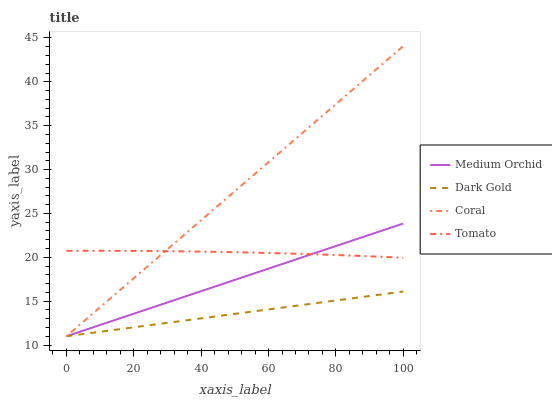Does Dark Gold have the minimum area under the curve?
Answer yes or no. Yes. Does Coral have the maximum area under the curve?
Answer yes or no. Yes. Does Medium Orchid have the minimum area under the curve?
Answer yes or no. No. Does Medium Orchid have the maximum area under the curve?
Answer yes or no. No. Is Dark Gold the smoothest?
Answer yes or no. Yes. Is Tomato the roughest?
Answer yes or no. Yes. Is Coral the smoothest?
Answer yes or no. No. Is Coral the roughest?
Answer yes or no. No. Does Coral have the lowest value?
Answer yes or no. Yes. Does Coral have the highest value?
Answer yes or no. Yes. Does Medium Orchid have the highest value?
Answer yes or no. No. Is Dark Gold less than Tomato?
Answer yes or no. Yes. Is Tomato greater than Dark Gold?
Answer yes or no. Yes. Does Tomato intersect Coral?
Answer yes or no. Yes. Is Tomato less than Coral?
Answer yes or no. No. Is Tomato greater than Coral?
Answer yes or no. No. Does Dark Gold intersect Tomato?
Answer yes or no. No. 